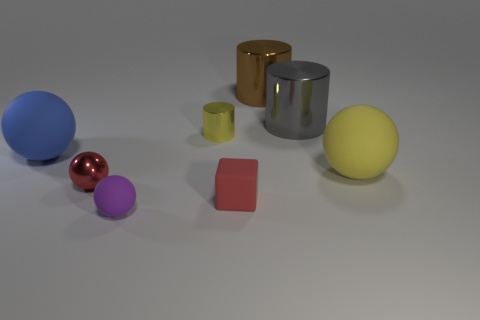Subtract all blocks. How many objects are left? 7 Add 2 big blue matte spheres. How many big blue matte spheres are left? 3 Add 4 red blocks. How many red blocks exist? 5 Add 1 blue spheres. How many objects exist? 9 Subtract all red spheres. How many spheres are left? 3 Subtract all large brown metallic cylinders. How many cylinders are left? 2 Subtract 0 blue cylinders. How many objects are left? 8 Subtract 2 balls. How many balls are left? 2 Subtract all yellow cubes. Subtract all cyan balls. How many cubes are left? 1 Subtract all green blocks. How many brown cylinders are left? 1 